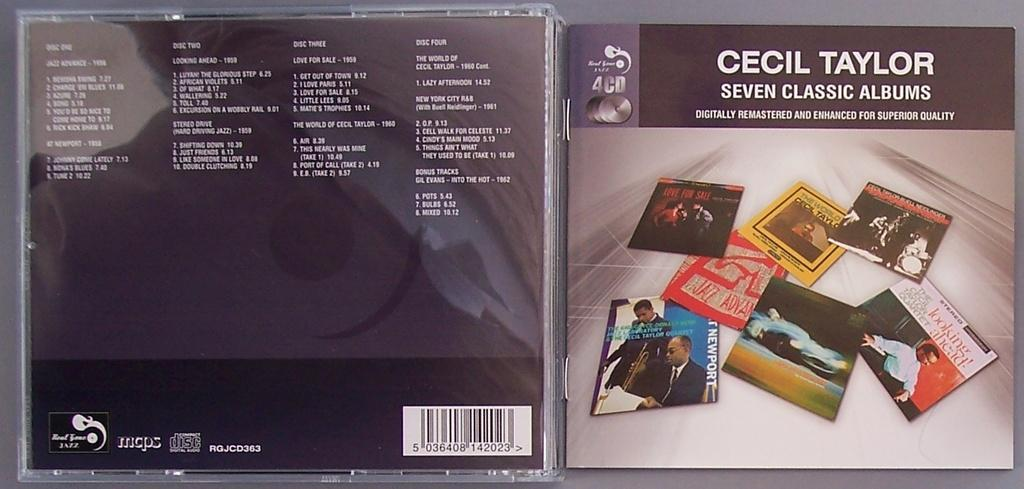Provide a one-sentence caption for the provided image. The cover of the Cecil Taylor album features covers of seven albums. 